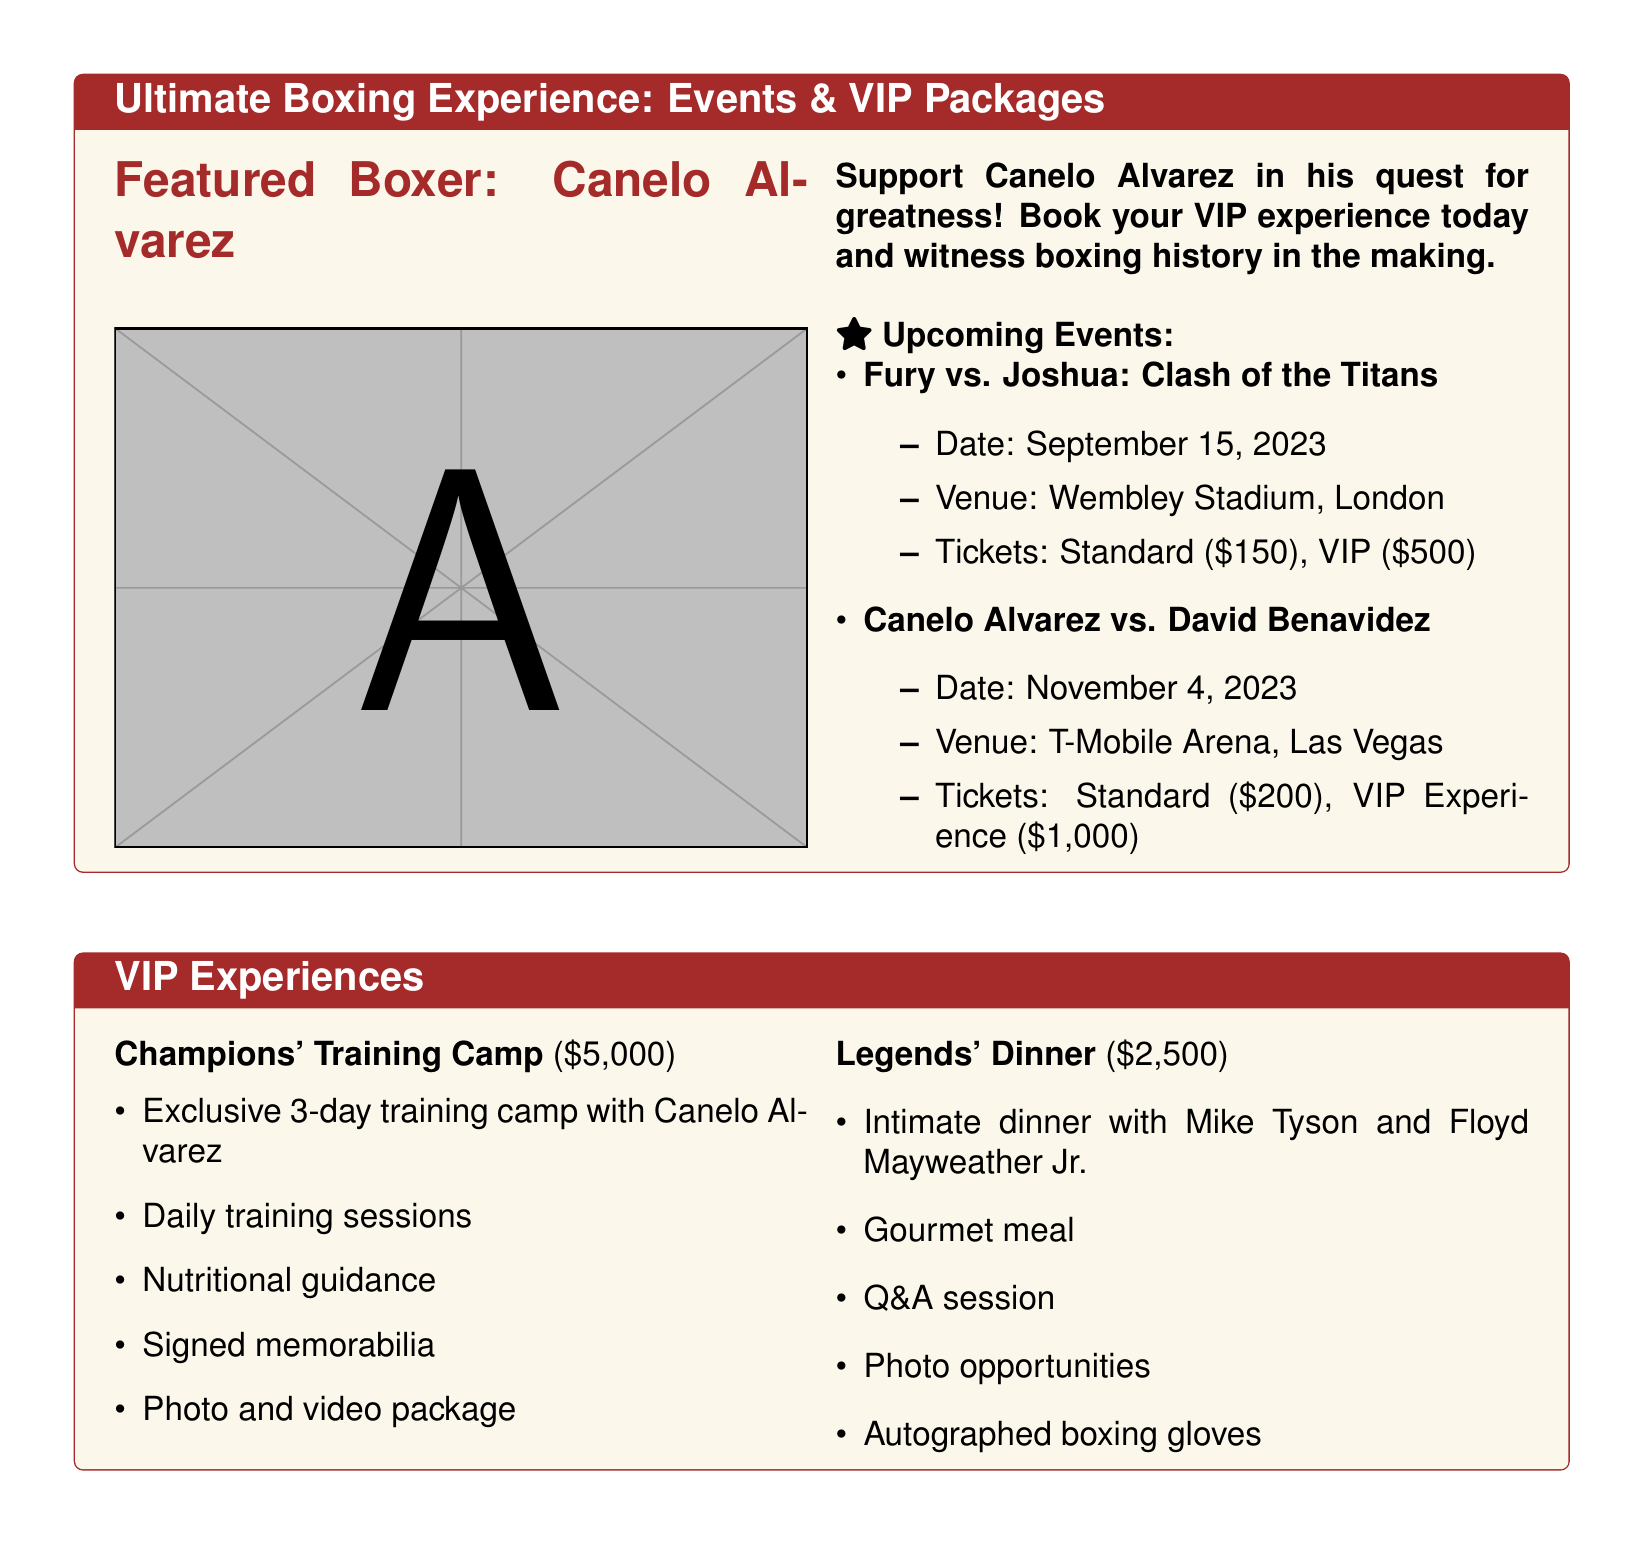what is the date of the Canelo Alvarez vs. David Benavidez fight? The date is provided in the upcoming events section of the document.
Answer: November 4, 2023 what is the ticket price for standard seating at the Fury vs. Joshua event? The ticket prices for the Fury vs. Joshua event are listed under the upcoming events section.
Answer: $150 who are the boxers featured in the Legends' Dinner package? The document details the event and lists Mike Tyson and Floyd Mayweather Jr. as the featured boxers.
Answer: Mike Tyson and Floyd Mayweather Jr how much does the VIP Experience for the Canelo Alvarez fight cost? The VIP Experience pricing is included in the document's upcoming events section.
Answer: $1,000 what is included in the Champions' Training Camp package? The document outlines the benefits of the Champions' Training Camp package under VIP Experiences.
Answer: Exclusive 3-day training camp which venue will host the Fury vs. Joshua match? The venue information can be found in the upcoming events section of the document.
Answer: Wembley Stadium how many days does the Champions' Training Camp last? The document specifies the duration of the training camp in the VIP Experiences section.
Answer: 3 days what type of meal is served at the Legends' Dinner? The document mentions the meal type provided during the Legends' Dinner in the VIP Experiences section.
Answer: Gourmet meal 